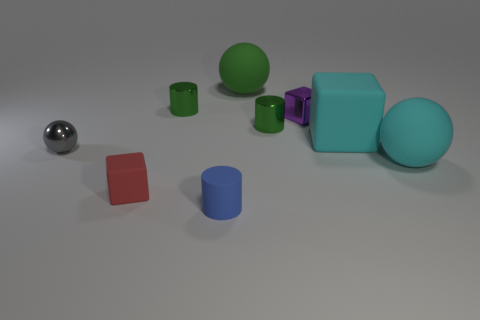What number of large matte objects have the same shape as the small red object?
Offer a very short reply. 1. There is a metallic cylinder to the right of the big green matte thing; how many things are on the right side of it?
Provide a short and direct response. 3. What number of shiny objects are small cylinders or cubes?
Offer a terse response. 3. Are there any tiny green objects that have the same material as the tiny gray sphere?
Your answer should be very brief. Yes. How many objects are matte blocks to the right of the small purple shiny block or tiny green objects that are to the left of the big green ball?
Offer a terse response. 2. Is the color of the large matte sphere that is on the right side of the small purple block the same as the large cube?
Your response must be concise. Yes. How many other things are the same color as the shiny ball?
Your answer should be very brief. 0. What is the purple thing made of?
Provide a short and direct response. Metal. There is a green shiny cylinder on the left side of the rubber cylinder; is its size the same as the tiny gray object?
Give a very brief answer. Yes. There is a purple shiny object that is the same shape as the small red thing; what is its size?
Make the answer very short. Small. 